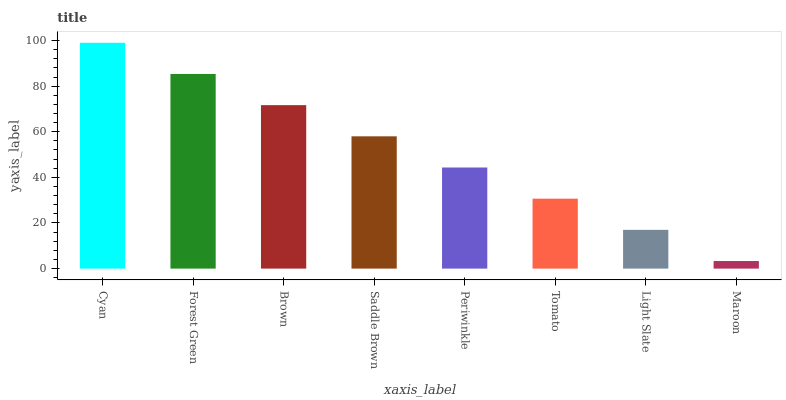Is Maroon the minimum?
Answer yes or no. Yes. Is Cyan the maximum?
Answer yes or no. Yes. Is Forest Green the minimum?
Answer yes or no. No. Is Forest Green the maximum?
Answer yes or no. No. Is Cyan greater than Forest Green?
Answer yes or no. Yes. Is Forest Green less than Cyan?
Answer yes or no. Yes. Is Forest Green greater than Cyan?
Answer yes or no. No. Is Cyan less than Forest Green?
Answer yes or no. No. Is Saddle Brown the high median?
Answer yes or no. Yes. Is Periwinkle the low median?
Answer yes or no. Yes. Is Periwinkle the high median?
Answer yes or no. No. Is Forest Green the low median?
Answer yes or no. No. 